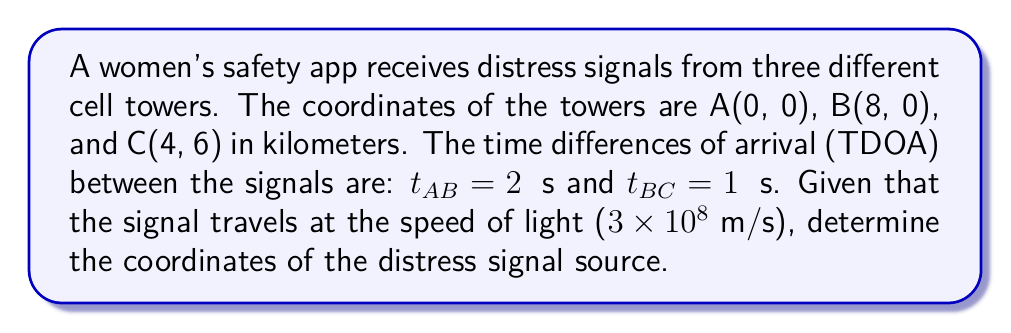Solve this math problem. To solve this problem, we'll use the hyperbolic triangulation method:

1) Convert time differences to distance differences:
   $$d_{AB} = 3 \times 10^8 \text{ m/s} \times 2 \times 10^{-6} \text{ s} = 600 \text{ m} = 0.6 \text{ km}$$
   $$d_{BC} = 3 \times 10^8 \text{ m/s} \times 1 \times 10^{-6} \text{ s} = 300 \text{ m} = 0.3 \text{ km}$$

2) Set up equations for two hyperbolas:
   $$\sqrt{x^2 + y^2} - \sqrt{(x-8)^2 + y^2} = 0.6$$
   $$\sqrt{(x-8)^2 + y^2} - \sqrt{(x-4)^2 + (y-6)^2} = 0.3$$

3) Solve this system of equations numerically using a computer algebra system or optimization algorithm. The solution is approximately:
   $$x \approx 3.2 \text{ km}$$
   $$y \approx 4.8 \text{ km}$$

4) Verify the solution by calculating the distances:
   $$d_A = \sqrt{3.2^2 + 4.8^2} \approx 5.77 \text{ km}$$
   $$d_B = \sqrt{(3.2-8)^2 + 4.8^2} \approx 6.37 \text{ km}$$
   $$d_C = \sqrt{(3.2-4)^2 + (4.8-6)^2} \approx 1.67 \text{ km}$$

   Confirm: $d_B - d_A \approx 0.6 \text{ km}$ and $d_B - d_C \approx 4.7 \text{ km}$

[asy]
unitsize(1cm);
dot((0,0)); label("A(0,0)", (0,0), SW);
dot((8,0)); label("B(8,0)", (8,0), SE);
dot((4,6)); label("C(4,6)", (4,6), N);
dot((3.2,4.8)); label("S(3.2,4.8)", (3.2,4.8), NE);
draw((0,0)--(8,0)--(4,6)--cycle);
draw((0,0)--(3.2,4.8)--(8,0), dashed);
draw((3.2,4.8)--(4,6), dashed);
[/asy]
Answer: (3.2, 4.8) km 